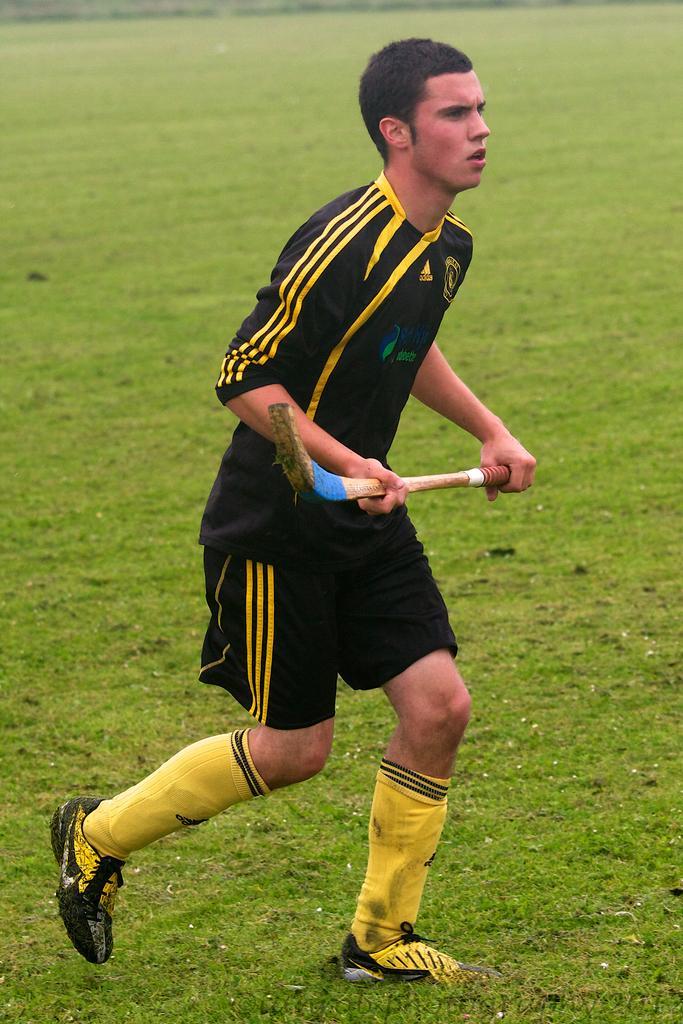Describe this image in one or two sentences. In the center of the image there is a person standing on the ground and holding bat. 